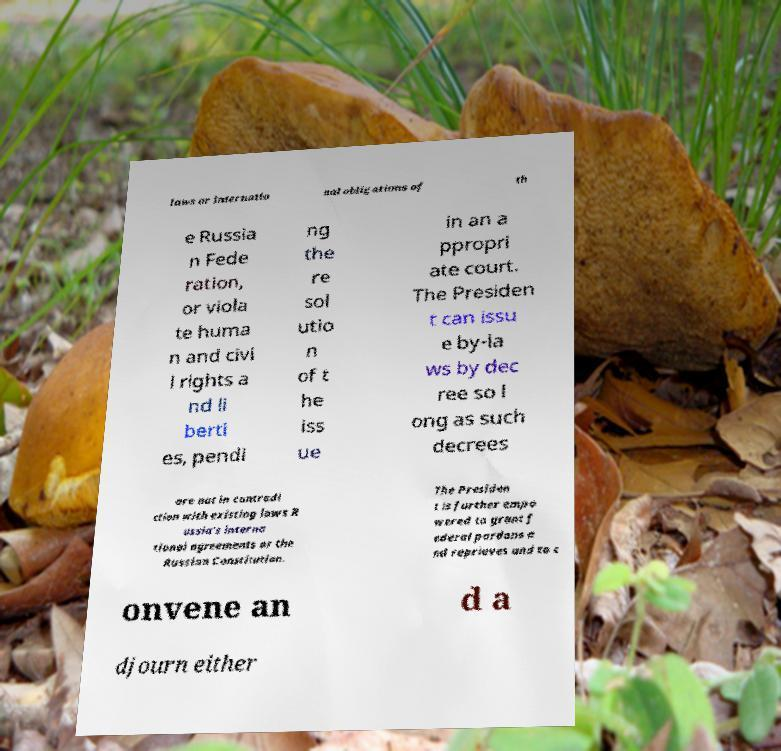Please identify and transcribe the text found in this image. laws or internatio nal obligations of th e Russia n Fede ration, or viola te huma n and civi l rights a nd li berti es, pendi ng the re sol utio n of t he iss ue in an a ppropri ate court. The Presiden t can issu e by-la ws by dec ree so l ong as such decrees are not in contradi ction with existing laws R ussia's interna tional agreements or the Russian Constitution. The Presiden t is further empo wered to grant f ederal pardons a nd reprieves and to c onvene an d a djourn either 